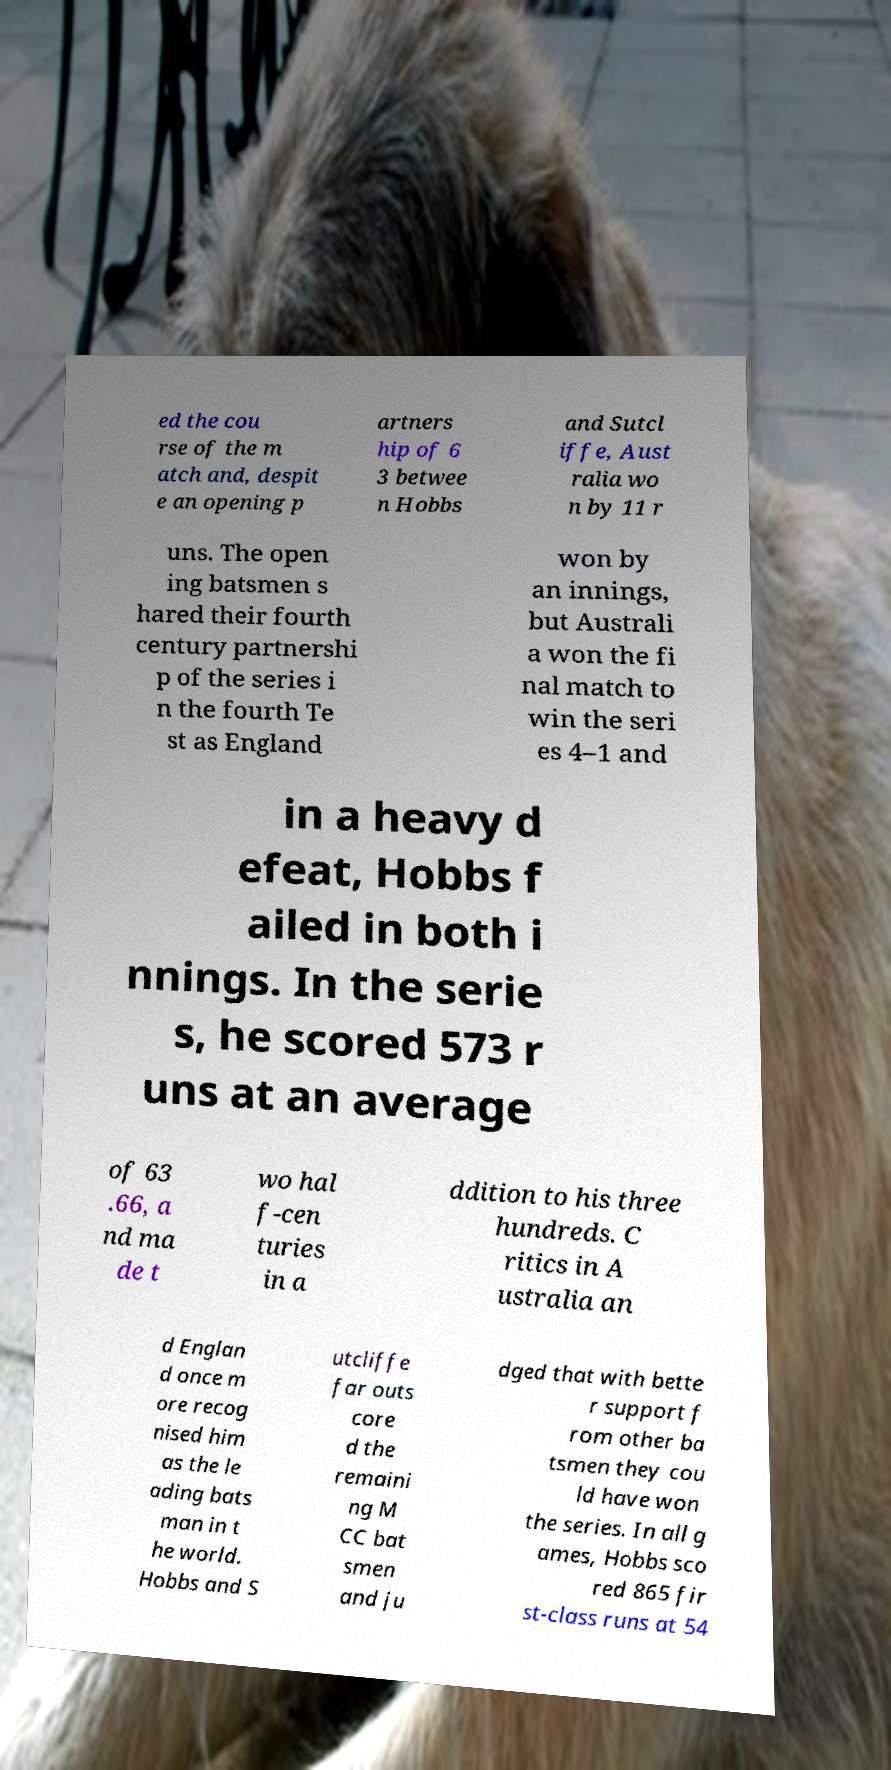Please identify and transcribe the text found in this image. ed the cou rse of the m atch and, despit e an opening p artners hip of 6 3 betwee n Hobbs and Sutcl iffe, Aust ralia wo n by 11 r uns. The open ing batsmen s hared their fourth century partnershi p of the series i n the fourth Te st as England won by an innings, but Australi a won the fi nal match to win the seri es 4–1 and in a heavy d efeat, Hobbs f ailed in both i nnings. In the serie s, he scored 573 r uns at an average of 63 .66, a nd ma de t wo hal f-cen turies in a ddition to his three hundreds. C ritics in A ustralia an d Englan d once m ore recog nised him as the le ading bats man in t he world. Hobbs and S utcliffe far outs core d the remaini ng M CC bat smen and ju dged that with bette r support f rom other ba tsmen they cou ld have won the series. In all g ames, Hobbs sco red 865 fir st-class runs at 54 